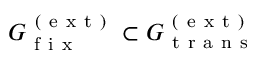<formula> <loc_0><loc_0><loc_500><loc_500>G _ { f i x } ^ { ( e x t ) } \subset G _ { t r a n s } ^ { ( e x t ) }</formula> 